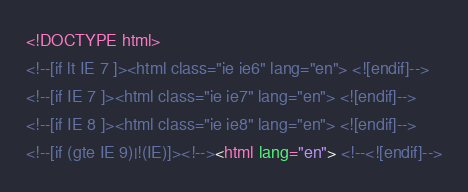<code> <loc_0><loc_0><loc_500><loc_500><_HTML_>
<!DOCTYPE html>
<!--[if lt IE 7 ]><html class="ie ie6" lang="en"> <![endif]-->
<!--[if IE 7 ]><html class="ie ie7" lang="en"> <![endif]-->
<!--[if IE 8 ]><html class="ie ie8" lang="en"> <![endif]-->
<!--[if (gte IE 9)|!(IE)]><!--><html lang="en"> <!--<![endif]-->
</code> 